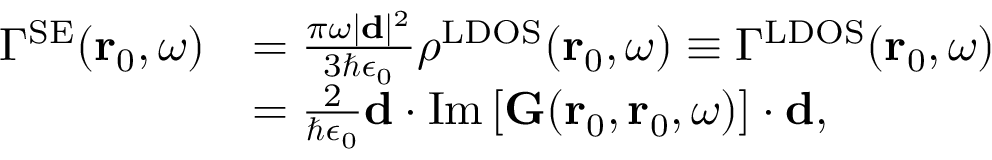<formula> <loc_0><loc_0><loc_500><loc_500>\begin{array} { r l } { \Gamma ^ { S E } ( r _ { 0 } , \omega ) } & { = \frac { \pi \omega | d | ^ { 2 } } { 3 \hbar { \epsilon } _ { 0 } } \rho ^ { L D O S } ( r _ { 0 } , \omega ) \equiv \Gamma ^ { L D O S } ( r _ { 0 } , \omega ) } \\ & { = \frac { 2 } { \hbar { \epsilon } _ { 0 } } d \cdot I m \left [ { G } ( r _ { 0 } , r _ { 0 } , \omega ) \right ] \cdot d , } \end{array}</formula> 